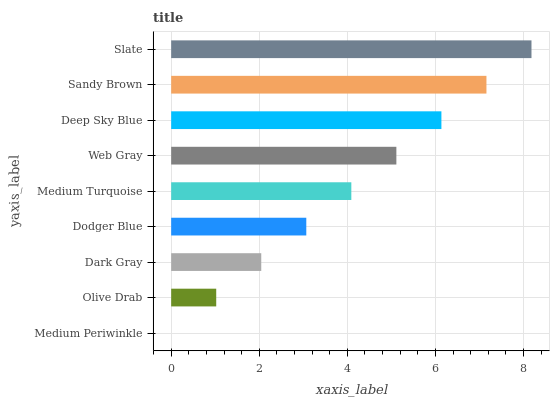Is Medium Periwinkle the minimum?
Answer yes or no. Yes. Is Slate the maximum?
Answer yes or no. Yes. Is Olive Drab the minimum?
Answer yes or no. No. Is Olive Drab the maximum?
Answer yes or no. No. Is Olive Drab greater than Medium Periwinkle?
Answer yes or no. Yes. Is Medium Periwinkle less than Olive Drab?
Answer yes or no. Yes. Is Medium Periwinkle greater than Olive Drab?
Answer yes or no. No. Is Olive Drab less than Medium Periwinkle?
Answer yes or no. No. Is Medium Turquoise the high median?
Answer yes or no. Yes. Is Medium Turquoise the low median?
Answer yes or no. Yes. Is Slate the high median?
Answer yes or no. No. Is Sandy Brown the low median?
Answer yes or no. No. 